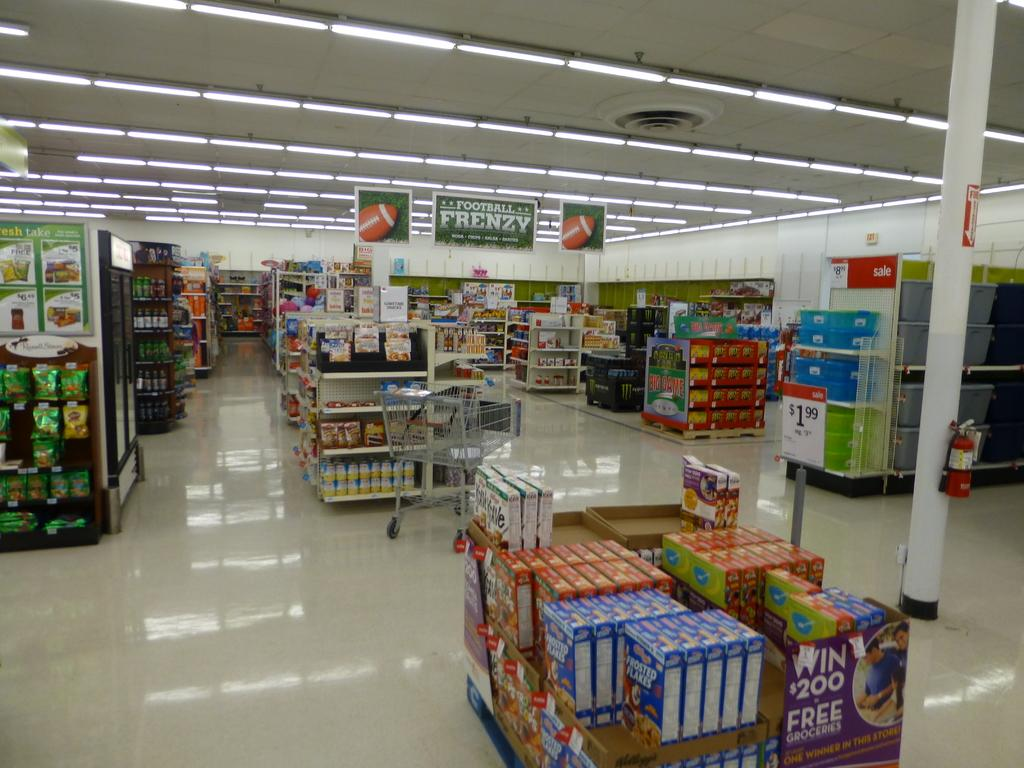<image>
Render a clear and concise summary of the photo. A store that is advertising football frenzy on a banner. 